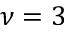<formula> <loc_0><loc_0><loc_500><loc_500>\nu = 3</formula> 